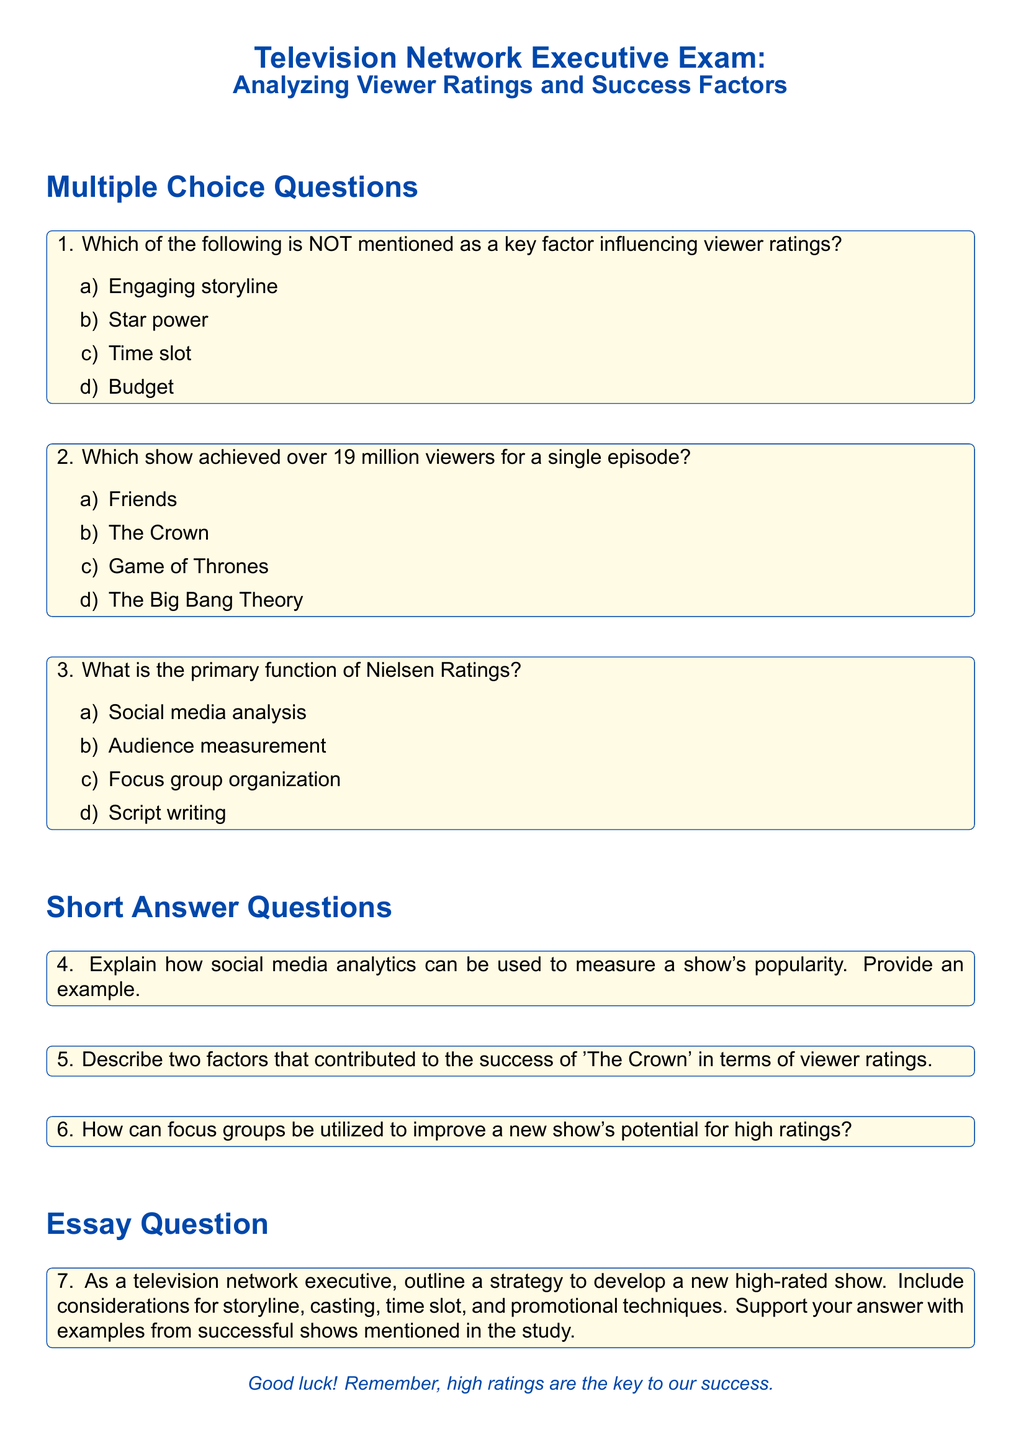What is the title of the exam? The title of the exam is presented at the beginning of the document, stating its focus on analyzing viewer ratings and success factors in television.
Answer: Analyzing Viewer Ratings and Success Factors Which color is used for the section titles? The document specifies a color theme, particularly stating that the section titles use a designated color throughout the text.
Answer: tvblue How many multiple-choice questions are included in the exam? The document lists multiple-choice questions under a specific section, allowing us to count them quickly.
Answer: 3 What is the focus of the essay question? The essay question requires outlining a strategy for developing a new high-rated show, considering various elements mentioned in the document.
Answer: Developing a new high-rated show Which show is noted for achieving over 19 million viewers? The document provides an option about a show that reached significant viewer numbers, indicating which one that is.
Answer: Game of Thrones What is the primary function of Nielsen Ratings? This is specifically outlined in the options provided in the multiple-choice section of the document, pointing to its main role in the television industry.
Answer: Audience measurement Name one of the factors mentioned that influenced viewer ratings. The document discusses several factors that affect viewer ratings, including storylines and star power, making it clear which elements are considered significant.
Answer: Engaging storyline What type of question follows the short answer questions? The structure of the document leads into another question type explicitly stated at the end of the short answer section.
Answer: Essay Question 